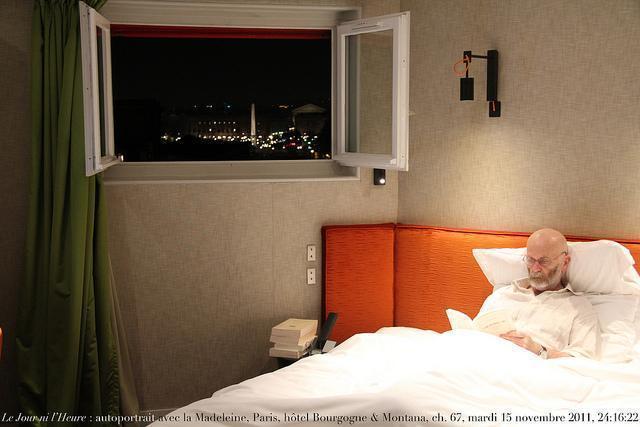Why does he need the light to be on?
Choose the right answer from the provided options to respond to the question.
Options: Reading, writing, cooking, watching. Reading. 